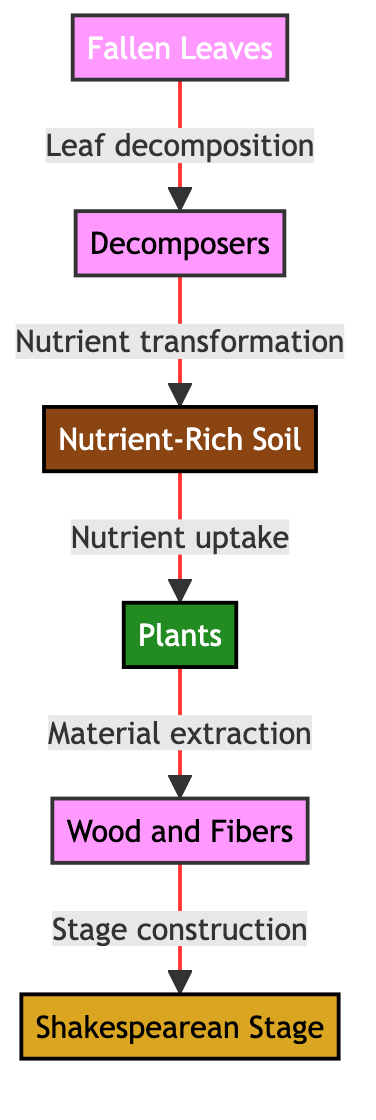What are the primary components involved in the nutrient cycling? The diagram lists the primary components involved in nutrient cycling as Fallen Leaves, Decomposers, Nutrient-Rich Soil, Plants, Wood and Fibers, and the Shakespearean Stage.
Answer: Fallen Leaves, Decomposers, Nutrient-Rich Soil, Plants, Wood and Fibers, Shakespearean Stage How many nodes are present in the diagram? The diagram has a total of six nodes, which correspond to Fallen Leaves, Decomposers, Nutrient-Rich Soil, Plants, Wood and Fibers, and Shakespearean Stage.
Answer: 6 What is produced as a result of leaf decomposition? According to the diagram, the process of leaf decomposition results in the creation of nutrient-rich soil.
Answer: Nutrient-Rich Soil Which stage(s) involve the extraction of materials from plants? The diagram indicates that the extraction of materials occurs from the Plants node, which leads to the Wood and Fibers node.
Answer: Wood and Fibers What is the final product in this nutrient cycling chain? The last step in the chain connects Wood and Fibers to the Shakespearean Stage, making the stage the final output of this nutrient cycling process.
Answer: Shakespearean Stage What type of organisms are represented by the Decomposers node? The Decomposers node represents organisms like fungi and bacteria that break down organic material such as fallen leaves.
Answer: Organisms How do nutrients transition from the soil to the plants? The transition of nutrients occurs through nutrient uptake from the Nutrient-Rich Soil to the Plants.
Answer: Nutrient uptake What is the relationship between the Decomposers and Nutrient-Rich Soil? The relationship is that decomposers transform nutrients during the decomposition process of fallen leaves into nutrient-rich soil.
Answer: Nutrient transformation 